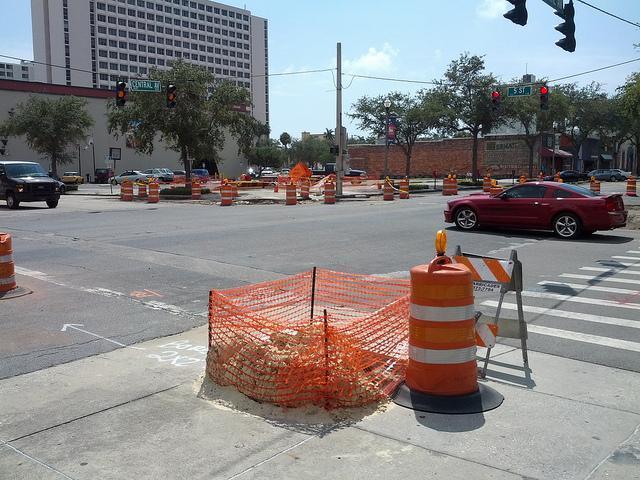How many cars are there?
Give a very brief answer. 2. 